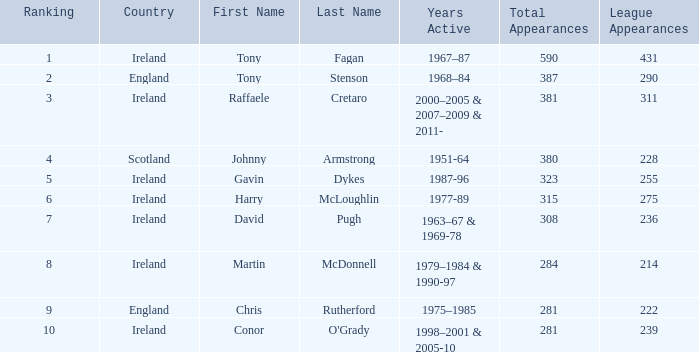What nationality has a ranking less than 7 with tony stenson as the name? England. 